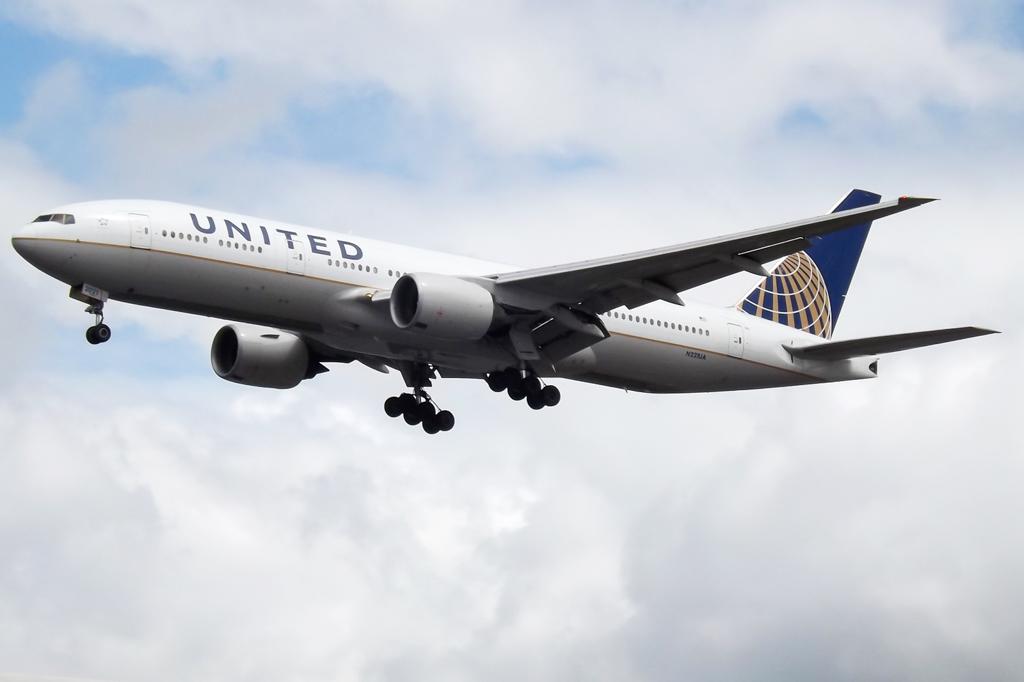What is the name of the planes airline?
Provide a short and direct response. United. 